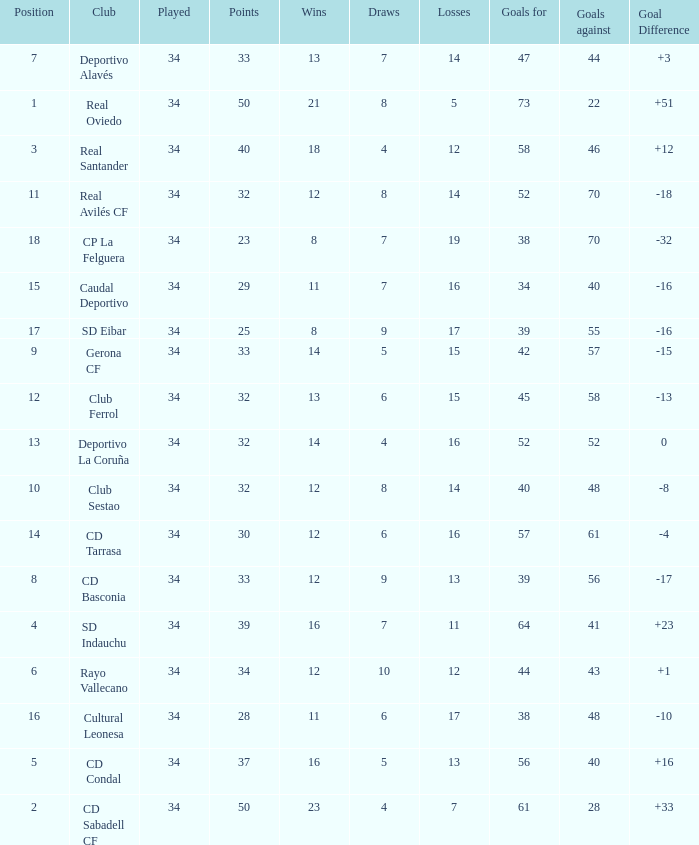Which Losses have a Goal Difference of -16, and less than 8 wins? None. 